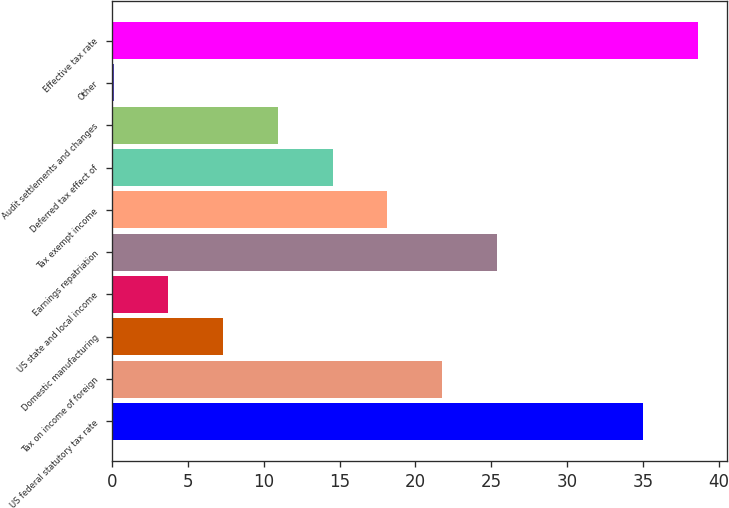Convert chart to OTSL. <chart><loc_0><loc_0><loc_500><loc_500><bar_chart><fcel>US federal statutory tax rate<fcel>Tax on income of foreign<fcel>Domestic manufacturing<fcel>US state and local income<fcel>Earnings repatriation<fcel>Tax exempt income<fcel>Deferred tax effect of<fcel>Audit settlements and changes<fcel>Other<fcel>Effective tax rate<nl><fcel>35<fcel>21.76<fcel>7.32<fcel>3.71<fcel>25.37<fcel>18.15<fcel>14.54<fcel>10.93<fcel>0.1<fcel>38.61<nl></chart> 